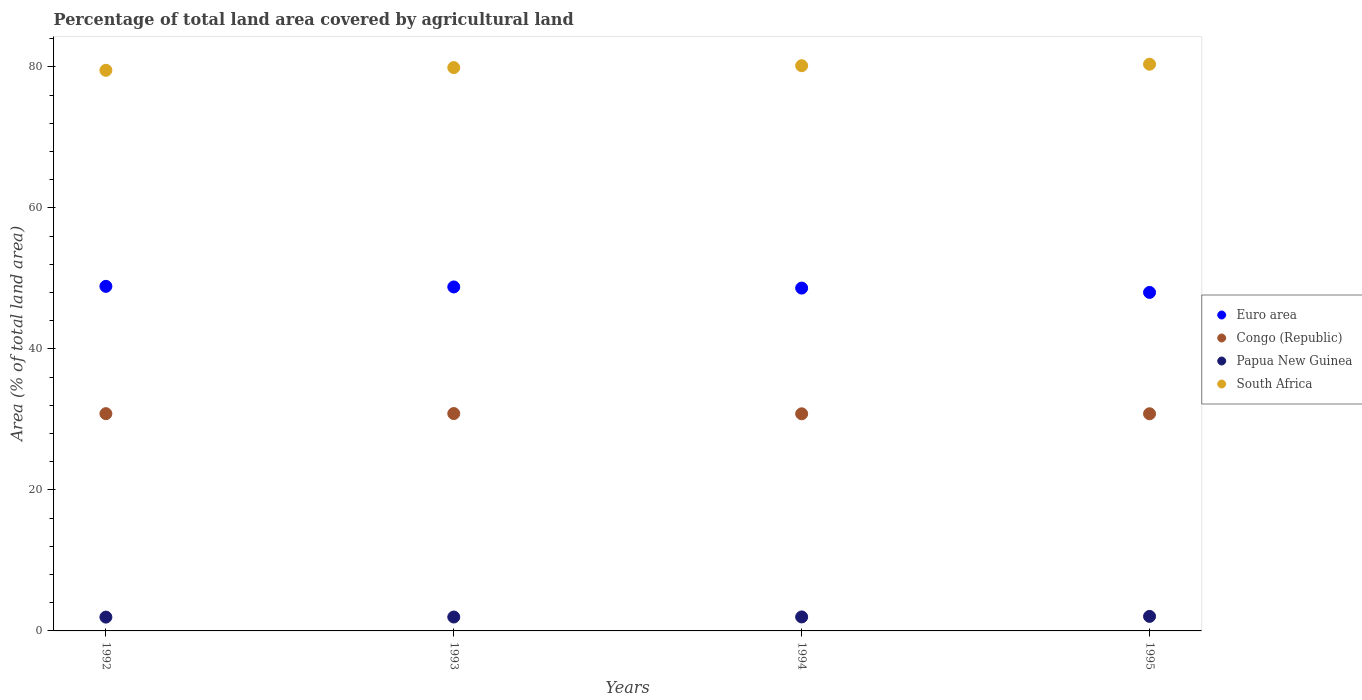Is the number of dotlines equal to the number of legend labels?
Give a very brief answer. Yes. What is the percentage of agricultural land in South Africa in 1993?
Offer a very short reply. 79.91. Across all years, what is the maximum percentage of agricultural land in Euro area?
Provide a short and direct response. 48.88. Across all years, what is the minimum percentage of agricultural land in Euro area?
Give a very brief answer. 48.02. In which year was the percentage of agricultural land in South Africa minimum?
Your answer should be very brief. 1992. What is the total percentage of agricultural land in Papua New Guinea in the graph?
Your answer should be compact. 7.98. What is the difference between the percentage of agricultural land in Congo (Republic) in 1993 and that in 1994?
Offer a very short reply. 0.04. What is the difference between the percentage of agricultural land in Papua New Guinea in 1994 and the percentage of agricultural land in Euro area in 1992?
Keep it short and to the point. -46.9. What is the average percentage of agricultural land in Congo (Republic) per year?
Provide a succinct answer. 30.81. In the year 1995, what is the difference between the percentage of agricultural land in Papua New Guinea and percentage of agricultural land in Euro area?
Your answer should be very brief. -45.96. In how many years, is the percentage of agricultural land in Euro area greater than 80 %?
Provide a short and direct response. 0. What is the ratio of the percentage of agricultural land in Papua New Guinea in 1993 to that in 1995?
Offer a terse response. 0.96. What is the difference between the highest and the second highest percentage of agricultural land in Papua New Guinea?
Your answer should be very brief. 0.08. What is the difference between the highest and the lowest percentage of agricultural land in South Africa?
Your response must be concise. 0.86. In how many years, is the percentage of agricultural land in Papua New Guinea greater than the average percentage of agricultural land in Papua New Guinea taken over all years?
Ensure brevity in your answer.  1. Does the percentage of agricultural land in South Africa monotonically increase over the years?
Provide a succinct answer. Yes. How many dotlines are there?
Offer a very short reply. 4. What is the difference between two consecutive major ticks on the Y-axis?
Provide a short and direct response. 20. Are the values on the major ticks of Y-axis written in scientific E-notation?
Provide a short and direct response. No. Does the graph contain any zero values?
Ensure brevity in your answer.  No. Where does the legend appear in the graph?
Provide a succinct answer. Center right. How many legend labels are there?
Offer a very short reply. 4. What is the title of the graph?
Your response must be concise. Percentage of total land area covered by agricultural land. What is the label or title of the Y-axis?
Your response must be concise. Area (% of total land area). What is the Area (% of total land area) in Euro area in 1992?
Offer a very short reply. 48.88. What is the Area (% of total land area) in Congo (Republic) in 1992?
Your answer should be compact. 30.82. What is the Area (% of total land area) of Papua New Guinea in 1992?
Your answer should be compact. 1.96. What is the Area (% of total land area) in South Africa in 1992?
Offer a terse response. 79.53. What is the Area (% of total land area) in Euro area in 1993?
Keep it short and to the point. 48.79. What is the Area (% of total land area) in Congo (Republic) in 1993?
Give a very brief answer. 30.83. What is the Area (% of total land area) of Papua New Guinea in 1993?
Ensure brevity in your answer.  1.97. What is the Area (% of total land area) in South Africa in 1993?
Provide a short and direct response. 79.91. What is the Area (% of total land area) in Euro area in 1994?
Offer a very short reply. 48.63. What is the Area (% of total land area) of Congo (Republic) in 1994?
Offer a terse response. 30.8. What is the Area (% of total land area) of Papua New Guinea in 1994?
Make the answer very short. 1.98. What is the Area (% of total land area) of South Africa in 1994?
Your answer should be very brief. 80.18. What is the Area (% of total land area) in Euro area in 1995?
Give a very brief answer. 48.02. What is the Area (% of total land area) of Congo (Republic) in 1995?
Your answer should be very brief. 30.81. What is the Area (% of total land area) of Papua New Guinea in 1995?
Ensure brevity in your answer.  2.06. What is the Area (% of total land area) in South Africa in 1995?
Make the answer very short. 80.39. Across all years, what is the maximum Area (% of total land area) of Euro area?
Your answer should be compact. 48.88. Across all years, what is the maximum Area (% of total land area) in Congo (Republic)?
Offer a very short reply. 30.83. Across all years, what is the maximum Area (% of total land area) of Papua New Guinea?
Your answer should be compact. 2.06. Across all years, what is the maximum Area (% of total land area) in South Africa?
Provide a succinct answer. 80.39. Across all years, what is the minimum Area (% of total land area) in Euro area?
Offer a very short reply. 48.02. Across all years, what is the minimum Area (% of total land area) of Congo (Republic)?
Keep it short and to the point. 30.8. Across all years, what is the minimum Area (% of total land area) in Papua New Guinea?
Ensure brevity in your answer.  1.96. Across all years, what is the minimum Area (% of total land area) of South Africa?
Keep it short and to the point. 79.53. What is the total Area (% of total land area) of Euro area in the graph?
Offer a terse response. 194.33. What is the total Area (% of total land area) in Congo (Republic) in the graph?
Your answer should be very brief. 123.26. What is the total Area (% of total land area) of Papua New Guinea in the graph?
Offer a terse response. 7.98. What is the total Area (% of total land area) in South Africa in the graph?
Keep it short and to the point. 320. What is the difference between the Area (% of total land area) in Euro area in 1992 and that in 1993?
Your response must be concise. 0.09. What is the difference between the Area (% of total land area) in Congo (Republic) in 1992 and that in 1993?
Your answer should be compact. -0.01. What is the difference between the Area (% of total land area) of Papua New Guinea in 1992 and that in 1993?
Ensure brevity in your answer.  -0.01. What is the difference between the Area (% of total land area) of South Africa in 1992 and that in 1993?
Give a very brief answer. -0.38. What is the difference between the Area (% of total land area) of Euro area in 1992 and that in 1994?
Keep it short and to the point. 0.25. What is the difference between the Area (% of total land area) in Congo (Republic) in 1992 and that in 1994?
Provide a short and direct response. 0.02. What is the difference between the Area (% of total land area) in Papua New Guinea in 1992 and that in 1994?
Your answer should be very brief. -0.02. What is the difference between the Area (% of total land area) in South Africa in 1992 and that in 1994?
Offer a very short reply. -0.65. What is the difference between the Area (% of total land area) of Euro area in 1992 and that in 1995?
Your answer should be compact. 0.86. What is the difference between the Area (% of total land area) of Congo (Republic) in 1992 and that in 1995?
Offer a very short reply. 0.01. What is the difference between the Area (% of total land area) in Papua New Guinea in 1992 and that in 1995?
Ensure brevity in your answer.  -0.1. What is the difference between the Area (% of total land area) of South Africa in 1992 and that in 1995?
Provide a short and direct response. -0.86. What is the difference between the Area (% of total land area) in Euro area in 1993 and that in 1994?
Your answer should be compact. 0.16. What is the difference between the Area (% of total land area) in Congo (Republic) in 1993 and that in 1994?
Provide a succinct answer. 0.04. What is the difference between the Area (% of total land area) of Papua New Guinea in 1993 and that in 1994?
Your answer should be very brief. -0.01. What is the difference between the Area (% of total land area) of South Africa in 1993 and that in 1994?
Provide a succinct answer. -0.27. What is the difference between the Area (% of total land area) of Euro area in 1993 and that in 1995?
Your response must be concise. 0.78. What is the difference between the Area (% of total land area) in Congo (Republic) in 1993 and that in 1995?
Give a very brief answer. 0.03. What is the difference between the Area (% of total land area) in Papua New Guinea in 1993 and that in 1995?
Offer a terse response. -0.09. What is the difference between the Area (% of total land area) in South Africa in 1993 and that in 1995?
Offer a very short reply. -0.48. What is the difference between the Area (% of total land area) in Euro area in 1994 and that in 1995?
Your answer should be very brief. 0.62. What is the difference between the Area (% of total land area) of Congo (Republic) in 1994 and that in 1995?
Make the answer very short. -0.01. What is the difference between the Area (% of total land area) of Papua New Guinea in 1994 and that in 1995?
Provide a short and direct response. -0.08. What is the difference between the Area (% of total land area) of South Africa in 1994 and that in 1995?
Ensure brevity in your answer.  -0.21. What is the difference between the Area (% of total land area) of Euro area in 1992 and the Area (% of total land area) of Congo (Republic) in 1993?
Provide a short and direct response. 18.05. What is the difference between the Area (% of total land area) of Euro area in 1992 and the Area (% of total land area) of Papua New Guinea in 1993?
Ensure brevity in your answer.  46.91. What is the difference between the Area (% of total land area) in Euro area in 1992 and the Area (% of total land area) in South Africa in 1993?
Provide a succinct answer. -31.03. What is the difference between the Area (% of total land area) in Congo (Republic) in 1992 and the Area (% of total land area) in Papua New Guinea in 1993?
Provide a short and direct response. 28.85. What is the difference between the Area (% of total land area) in Congo (Republic) in 1992 and the Area (% of total land area) in South Africa in 1993?
Offer a very short reply. -49.09. What is the difference between the Area (% of total land area) of Papua New Guinea in 1992 and the Area (% of total land area) of South Africa in 1993?
Your response must be concise. -77.95. What is the difference between the Area (% of total land area) in Euro area in 1992 and the Area (% of total land area) in Congo (Republic) in 1994?
Your answer should be very brief. 18.08. What is the difference between the Area (% of total land area) of Euro area in 1992 and the Area (% of total land area) of Papua New Guinea in 1994?
Your response must be concise. 46.9. What is the difference between the Area (% of total land area) of Euro area in 1992 and the Area (% of total land area) of South Africa in 1994?
Your response must be concise. -31.3. What is the difference between the Area (% of total land area) in Congo (Republic) in 1992 and the Area (% of total land area) in Papua New Guinea in 1994?
Your answer should be very brief. 28.84. What is the difference between the Area (% of total land area) of Congo (Republic) in 1992 and the Area (% of total land area) of South Africa in 1994?
Keep it short and to the point. -49.36. What is the difference between the Area (% of total land area) in Papua New Guinea in 1992 and the Area (% of total land area) in South Africa in 1994?
Make the answer very short. -78.22. What is the difference between the Area (% of total land area) of Euro area in 1992 and the Area (% of total land area) of Congo (Republic) in 1995?
Keep it short and to the point. 18.08. What is the difference between the Area (% of total land area) in Euro area in 1992 and the Area (% of total land area) in Papua New Guinea in 1995?
Provide a succinct answer. 46.82. What is the difference between the Area (% of total land area) in Euro area in 1992 and the Area (% of total land area) in South Africa in 1995?
Your answer should be compact. -31.51. What is the difference between the Area (% of total land area) in Congo (Republic) in 1992 and the Area (% of total land area) in Papua New Guinea in 1995?
Make the answer very short. 28.76. What is the difference between the Area (% of total land area) of Congo (Republic) in 1992 and the Area (% of total land area) of South Africa in 1995?
Make the answer very short. -49.57. What is the difference between the Area (% of total land area) of Papua New Guinea in 1992 and the Area (% of total land area) of South Africa in 1995?
Keep it short and to the point. -78.43. What is the difference between the Area (% of total land area) of Euro area in 1993 and the Area (% of total land area) of Congo (Republic) in 1994?
Offer a terse response. 18. What is the difference between the Area (% of total land area) in Euro area in 1993 and the Area (% of total land area) in Papua New Guinea in 1994?
Make the answer very short. 46.81. What is the difference between the Area (% of total land area) in Euro area in 1993 and the Area (% of total land area) in South Africa in 1994?
Make the answer very short. -31.38. What is the difference between the Area (% of total land area) of Congo (Republic) in 1993 and the Area (% of total land area) of Papua New Guinea in 1994?
Your response must be concise. 28.85. What is the difference between the Area (% of total land area) of Congo (Republic) in 1993 and the Area (% of total land area) of South Africa in 1994?
Your response must be concise. -49.34. What is the difference between the Area (% of total land area) of Papua New Guinea in 1993 and the Area (% of total land area) of South Africa in 1994?
Provide a short and direct response. -78.21. What is the difference between the Area (% of total land area) in Euro area in 1993 and the Area (% of total land area) in Congo (Republic) in 1995?
Give a very brief answer. 17.99. What is the difference between the Area (% of total land area) in Euro area in 1993 and the Area (% of total land area) in Papua New Guinea in 1995?
Provide a succinct answer. 46.73. What is the difference between the Area (% of total land area) in Euro area in 1993 and the Area (% of total land area) in South Africa in 1995?
Your response must be concise. -31.59. What is the difference between the Area (% of total land area) in Congo (Republic) in 1993 and the Area (% of total land area) in Papua New Guinea in 1995?
Your answer should be compact. 28.77. What is the difference between the Area (% of total land area) of Congo (Republic) in 1993 and the Area (% of total land area) of South Africa in 1995?
Give a very brief answer. -49.56. What is the difference between the Area (% of total land area) of Papua New Guinea in 1993 and the Area (% of total land area) of South Africa in 1995?
Your answer should be very brief. -78.42. What is the difference between the Area (% of total land area) of Euro area in 1994 and the Area (% of total land area) of Congo (Republic) in 1995?
Provide a short and direct response. 17.83. What is the difference between the Area (% of total land area) in Euro area in 1994 and the Area (% of total land area) in Papua New Guinea in 1995?
Keep it short and to the point. 46.57. What is the difference between the Area (% of total land area) in Euro area in 1994 and the Area (% of total land area) in South Africa in 1995?
Your answer should be compact. -31.76. What is the difference between the Area (% of total land area) in Congo (Republic) in 1994 and the Area (% of total land area) in Papua New Guinea in 1995?
Make the answer very short. 28.74. What is the difference between the Area (% of total land area) in Congo (Republic) in 1994 and the Area (% of total land area) in South Africa in 1995?
Ensure brevity in your answer.  -49.59. What is the difference between the Area (% of total land area) in Papua New Guinea in 1994 and the Area (% of total land area) in South Africa in 1995?
Provide a succinct answer. -78.41. What is the average Area (% of total land area) of Euro area per year?
Provide a succinct answer. 48.58. What is the average Area (% of total land area) in Congo (Republic) per year?
Make the answer very short. 30.81. What is the average Area (% of total land area) in Papua New Guinea per year?
Give a very brief answer. 1.99. What is the average Area (% of total land area) of South Africa per year?
Give a very brief answer. 80. In the year 1992, what is the difference between the Area (% of total land area) in Euro area and Area (% of total land area) in Congo (Republic)?
Your answer should be very brief. 18.06. In the year 1992, what is the difference between the Area (% of total land area) of Euro area and Area (% of total land area) of Papua New Guinea?
Your response must be concise. 46.92. In the year 1992, what is the difference between the Area (% of total land area) of Euro area and Area (% of total land area) of South Africa?
Keep it short and to the point. -30.65. In the year 1992, what is the difference between the Area (% of total land area) in Congo (Republic) and Area (% of total land area) in Papua New Guinea?
Provide a short and direct response. 28.86. In the year 1992, what is the difference between the Area (% of total land area) in Congo (Republic) and Area (% of total land area) in South Africa?
Make the answer very short. -48.71. In the year 1992, what is the difference between the Area (% of total land area) in Papua New Guinea and Area (% of total land area) in South Africa?
Your answer should be compact. -77.57. In the year 1993, what is the difference between the Area (% of total land area) in Euro area and Area (% of total land area) in Congo (Republic)?
Provide a succinct answer. 17.96. In the year 1993, what is the difference between the Area (% of total land area) of Euro area and Area (% of total land area) of Papua New Guinea?
Make the answer very short. 46.82. In the year 1993, what is the difference between the Area (% of total land area) in Euro area and Area (% of total land area) in South Africa?
Offer a terse response. -31.11. In the year 1993, what is the difference between the Area (% of total land area) of Congo (Republic) and Area (% of total land area) of Papua New Guinea?
Offer a terse response. 28.86. In the year 1993, what is the difference between the Area (% of total land area) of Congo (Republic) and Area (% of total land area) of South Africa?
Offer a very short reply. -49.07. In the year 1993, what is the difference between the Area (% of total land area) in Papua New Guinea and Area (% of total land area) in South Africa?
Offer a terse response. -77.94. In the year 1994, what is the difference between the Area (% of total land area) in Euro area and Area (% of total land area) in Congo (Republic)?
Provide a short and direct response. 17.83. In the year 1994, what is the difference between the Area (% of total land area) of Euro area and Area (% of total land area) of Papua New Guinea?
Give a very brief answer. 46.65. In the year 1994, what is the difference between the Area (% of total land area) of Euro area and Area (% of total land area) of South Africa?
Give a very brief answer. -31.55. In the year 1994, what is the difference between the Area (% of total land area) in Congo (Republic) and Area (% of total land area) in Papua New Guinea?
Your answer should be compact. 28.82. In the year 1994, what is the difference between the Area (% of total land area) in Congo (Republic) and Area (% of total land area) in South Africa?
Ensure brevity in your answer.  -49.38. In the year 1994, what is the difference between the Area (% of total land area) in Papua New Guinea and Area (% of total land area) in South Africa?
Provide a succinct answer. -78.2. In the year 1995, what is the difference between the Area (% of total land area) in Euro area and Area (% of total land area) in Congo (Republic)?
Your response must be concise. 17.21. In the year 1995, what is the difference between the Area (% of total land area) in Euro area and Area (% of total land area) in Papua New Guinea?
Give a very brief answer. 45.96. In the year 1995, what is the difference between the Area (% of total land area) of Euro area and Area (% of total land area) of South Africa?
Your answer should be very brief. -32.37. In the year 1995, what is the difference between the Area (% of total land area) of Congo (Republic) and Area (% of total land area) of Papua New Guinea?
Your answer should be compact. 28.74. In the year 1995, what is the difference between the Area (% of total land area) of Congo (Republic) and Area (% of total land area) of South Africa?
Provide a short and direct response. -49.58. In the year 1995, what is the difference between the Area (% of total land area) in Papua New Guinea and Area (% of total land area) in South Africa?
Provide a succinct answer. -78.33. What is the ratio of the Area (% of total land area) in Congo (Republic) in 1992 to that in 1993?
Give a very brief answer. 1. What is the ratio of the Area (% of total land area) of Papua New Guinea in 1992 to that in 1993?
Provide a succinct answer. 0.99. What is the ratio of the Area (% of total land area) in Euro area in 1992 to that in 1994?
Your response must be concise. 1.01. What is the ratio of the Area (% of total land area) of Congo (Republic) in 1992 to that in 1994?
Offer a terse response. 1. What is the ratio of the Area (% of total land area) in Euro area in 1992 to that in 1995?
Your answer should be very brief. 1.02. What is the ratio of the Area (% of total land area) in Papua New Guinea in 1992 to that in 1995?
Keep it short and to the point. 0.95. What is the ratio of the Area (% of total land area) of South Africa in 1992 to that in 1995?
Give a very brief answer. 0.99. What is the ratio of the Area (% of total land area) of Euro area in 1993 to that in 1994?
Offer a very short reply. 1. What is the ratio of the Area (% of total land area) in Congo (Republic) in 1993 to that in 1994?
Offer a terse response. 1. What is the ratio of the Area (% of total land area) of Papua New Guinea in 1993 to that in 1994?
Provide a succinct answer. 0.99. What is the ratio of the Area (% of total land area) in South Africa in 1993 to that in 1994?
Offer a terse response. 1. What is the ratio of the Area (% of total land area) in Euro area in 1993 to that in 1995?
Ensure brevity in your answer.  1.02. What is the ratio of the Area (% of total land area) in Papua New Guinea in 1993 to that in 1995?
Ensure brevity in your answer.  0.96. What is the ratio of the Area (% of total land area) in Euro area in 1994 to that in 1995?
Offer a terse response. 1.01. What is the ratio of the Area (% of total land area) in Congo (Republic) in 1994 to that in 1995?
Your answer should be compact. 1. What is the ratio of the Area (% of total land area) in Papua New Guinea in 1994 to that in 1995?
Make the answer very short. 0.96. What is the ratio of the Area (% of total land area) of South Africa in 1994 to that in 1995?
Make the answer very short. 1. What is the difference between the highest and the second highest Area (% of total land area) of Euro area?
Your answer should be very brief. 0.09. What is the difference between the highest and the second highest Area (% of total land area) of Congo (Republic)?
Provide a succinct answer. 0.01. What is the difference between the highest and the second highest Area (% of total land area) in Papua New Guinea?
Your answer should be compact. 0.08. What is the difference between the highest and the second highest Area (% of total land area) in South Africa?
Your response must be concise. 0.21. What is the difference between the highest and the lowest Area (% of total land area) in Euro area?
Provide a short and direct response. 0.86. What is the difference between the highest and the lowest Area (% of total land area) in Congo (Republic)?
Ensure brevity in your answer.  0.04. What is the difference between the highest and the lowest Area (% of total land area) in Papua New Guinea?
Offer a very short reply. 0.1. What is the difference between the highest and the lowest Area (% of total land area) of South Africa?
Provide a short and direct response. 0.86. 